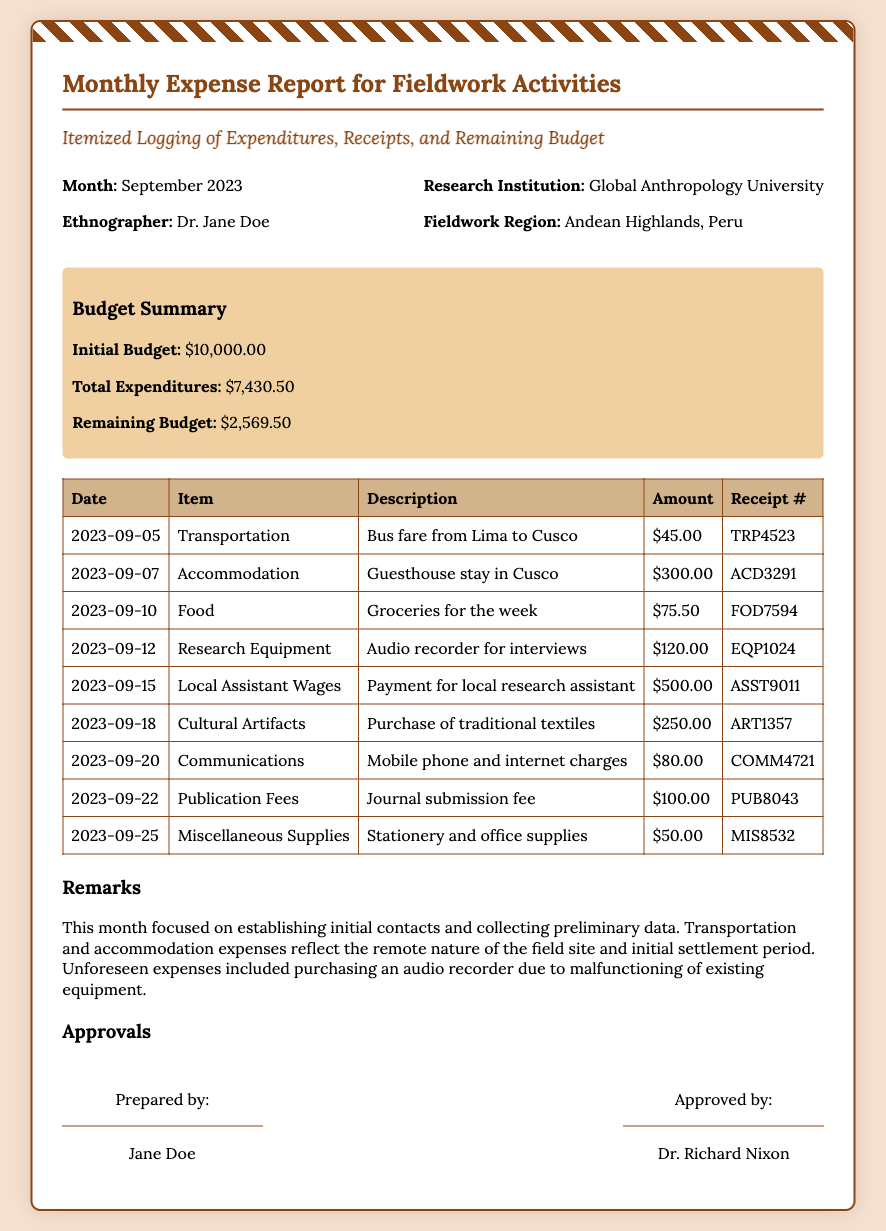What is the month of the report? The report is for the month specified at the beginning of the document.
Answer: September 2023 Who is the ethnographer? The name of the ethnographer is mentioned in the header section of the envelope.
Answer: Dr. Jane Doe What is the initial budget? The initial budget is listed in the budget summary section.
Answer: $10,000.00 What was the amount spent on accommodation? The expense table shows the amount paid for accommodation under the relevant entry.
Answer: $300.00 What are the total expenditures? The total expenditures are provided in the budget summary section of the document.
Answer: $7,430.50 How much is the remaining budget? The remaining budget is calculated and displayed in the budget summary.
Answer: $2,569.50 What was the expense for local assistant wages? The expense for local assistant wages can be found in the expense items table.
Answer: $500.00 What is noted about the unforeseen expenses? The remarks section discusses challenges faced, including unforeseen expenses.
Answer: Purchasing an audio recorder Who approved the report? The person who approved the report is identified in the approvals section of the document.
Answer: Dr. Richard Nixon 